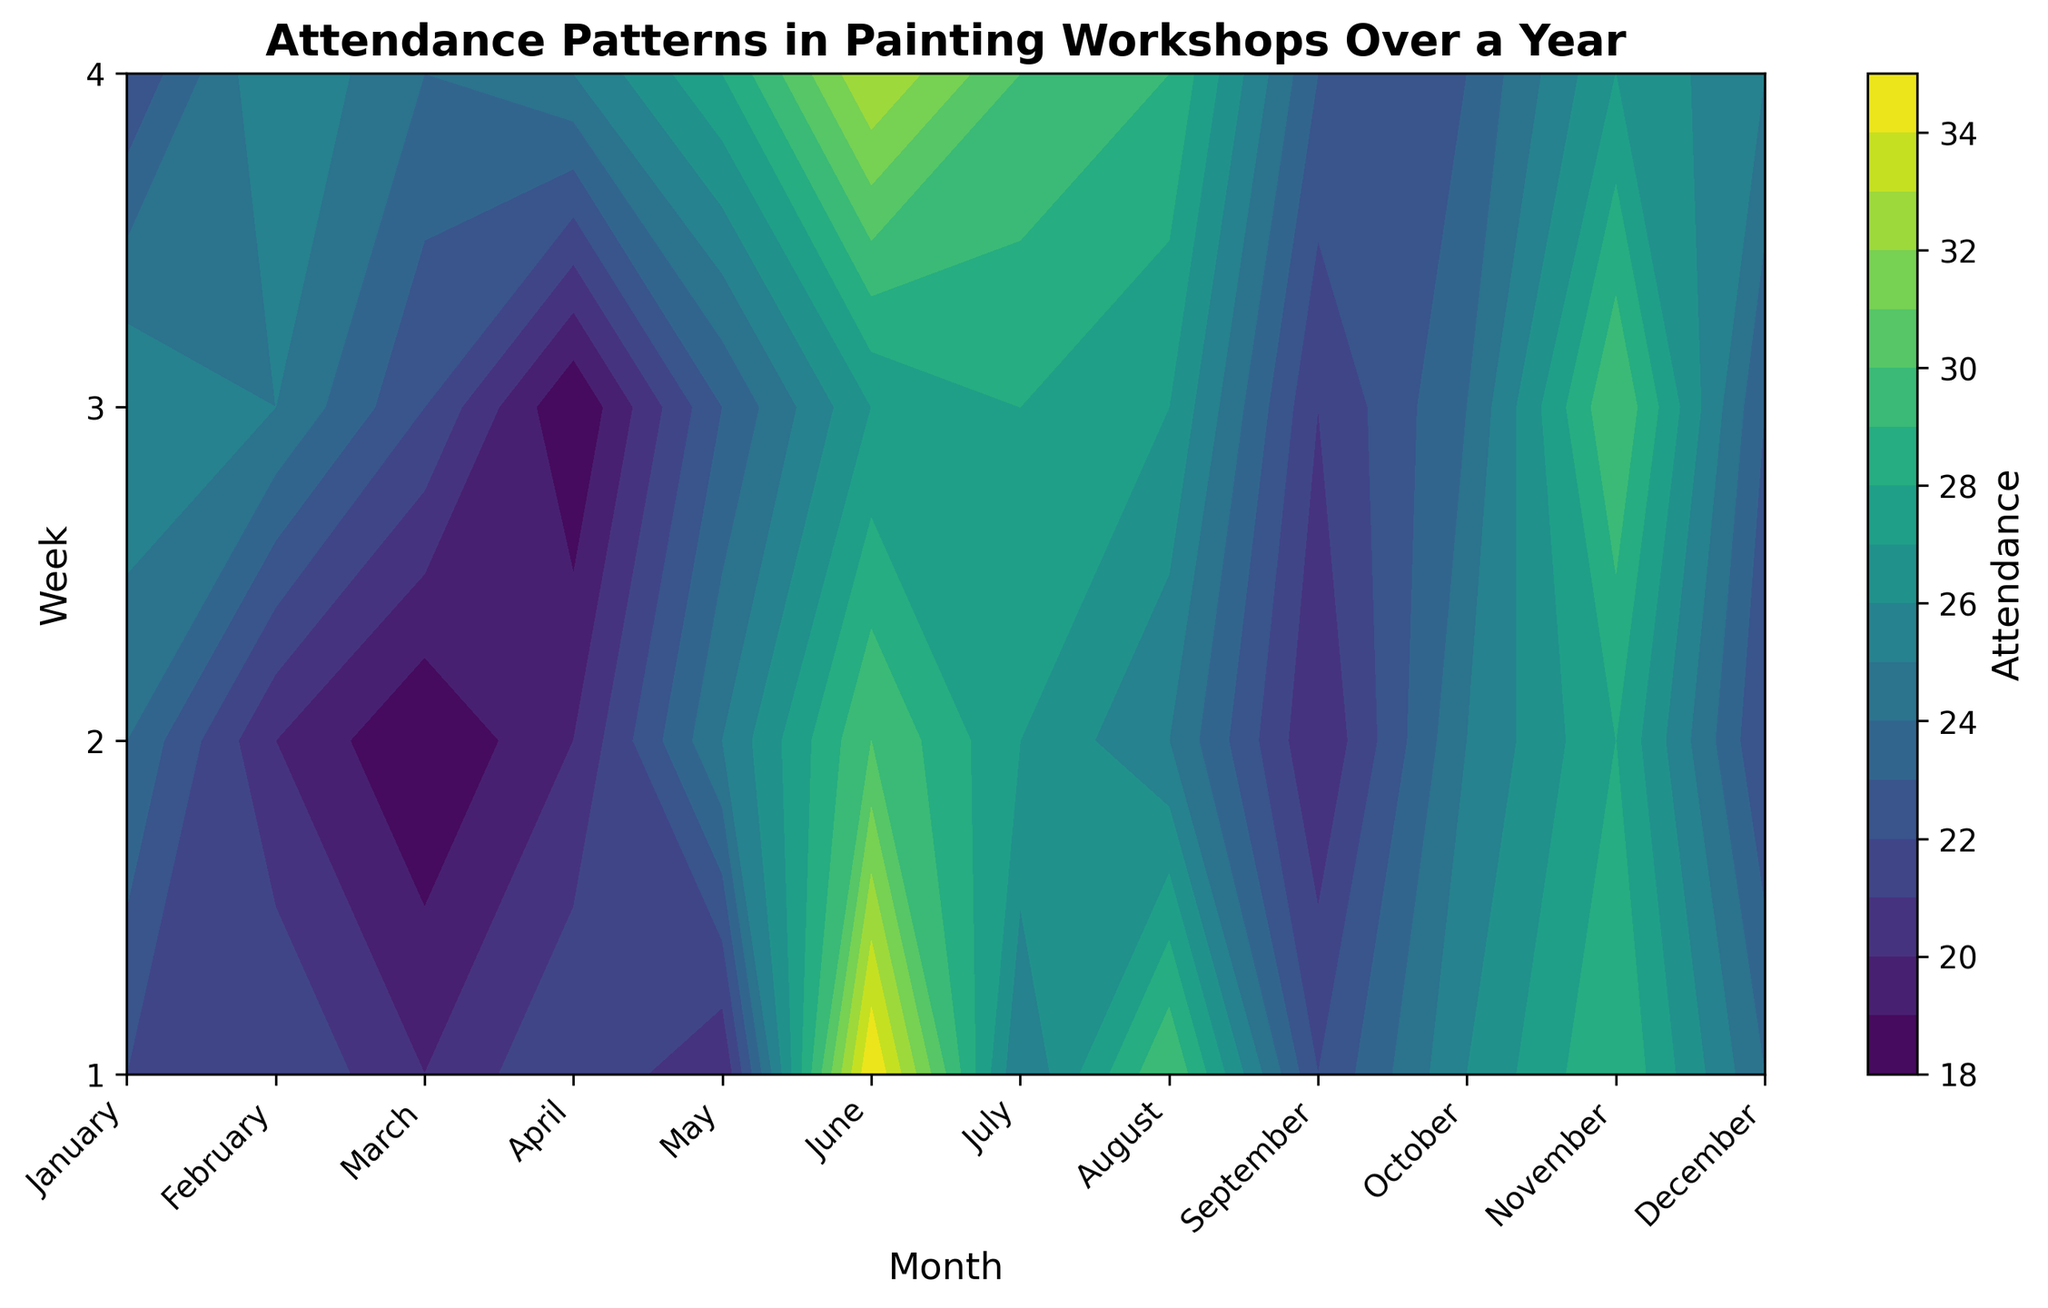What month has the highest average attendance? To determine the month with the highest average attendance, look at all weeks within each month and calculate the average. The highest average value indicates the month.
Answer: July In which week is the attendance consistently low across different months? Examine the attendance values for each week across all months. The week which consistently has lower values compared to other weeks is the one with consistently low attendance.
Answer: Week 4 of December Which month has the greatest variability in attendance? Variability can be measured by the range or fluctuation in attendance values. Check the month where the difference between the highest and lowest attendance is the greatest.
Answer: October Compare the highest attendance between January and July. Which month shows higher peak attendance? Look at the maximum attendance in July and January. Compare these peak values to see which is higher.
Answer: July What visual pattern is evident for the attendance in December? Observe the color and contour gradient for December. The pattern should illustrate how the attendance values change across the weeks.
Answer: Generally low attendance Does any month show increasing attendance as weeks progress? Identify the trend in attendance within individual months. The month with a clear increasing trend across weeks will fit this pattern.
Answer: March How does the attendance in February compare to that in September? Compare the attendance values week-by-week for both February and September to see which is higher or if they are similar.
Answer: Similar Which week in July has the highest attendance? Look at the attendance values for all the weeks in July and identify the week with the highest value.
Answer: Week 1 Is there a month where attendance does not change much week to week? Identify a month where the weekly attendance values are very close to each other, indicating minimal fluctuation.
Answer: April What is the general trend of attendance over the summer months (June, July, August)? Examine the attendance values over the weeks of June, July, and August to identify any trends, whether increasing, decreasing, or stable.
Answer: Generally increasing in July, decreasing in August 